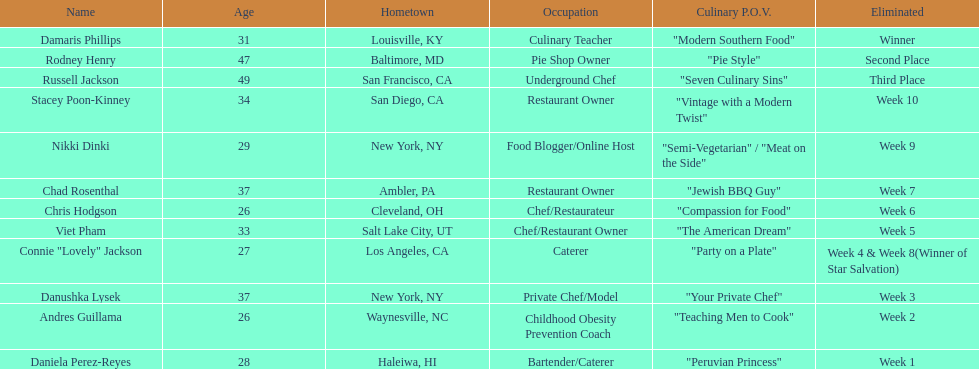Who were the individuals in the food network? Damaris Phillips, Rodney Henry, Russell Jackson, Stacey Poon-Kinney, Nikki Dinki, Chad Rosenthal, Chris Hodgson, Viet Pham, Connie "Lovely" Jackson, Danushka Lysek, Andres Guillama, Daniela Perez-Reyes. When was nikki dinki removed? Week 9. When was viet pham removed? Week 5. Which of these two occurred first? Week 5. Who was eliminated this week? Viet Pham. 